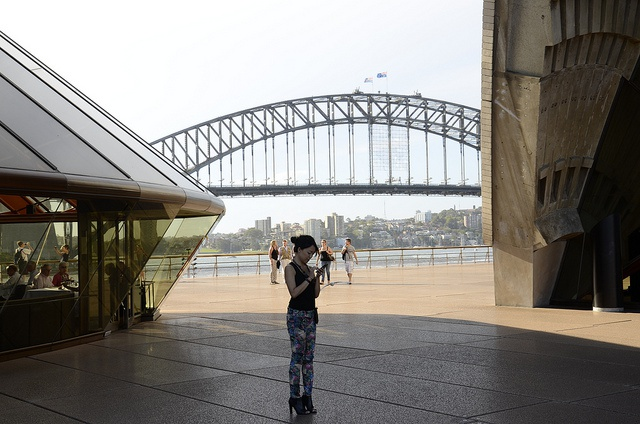Describe the objects in this image and their specific colors. I can see people in white, black, gray, and navy tones, people in white, black, gray, and darkgray tones, people in white, darkgray, and gray tones, people in white, black, gray, and tan tones, and people in white, black, gray, and tan tones in this image. 